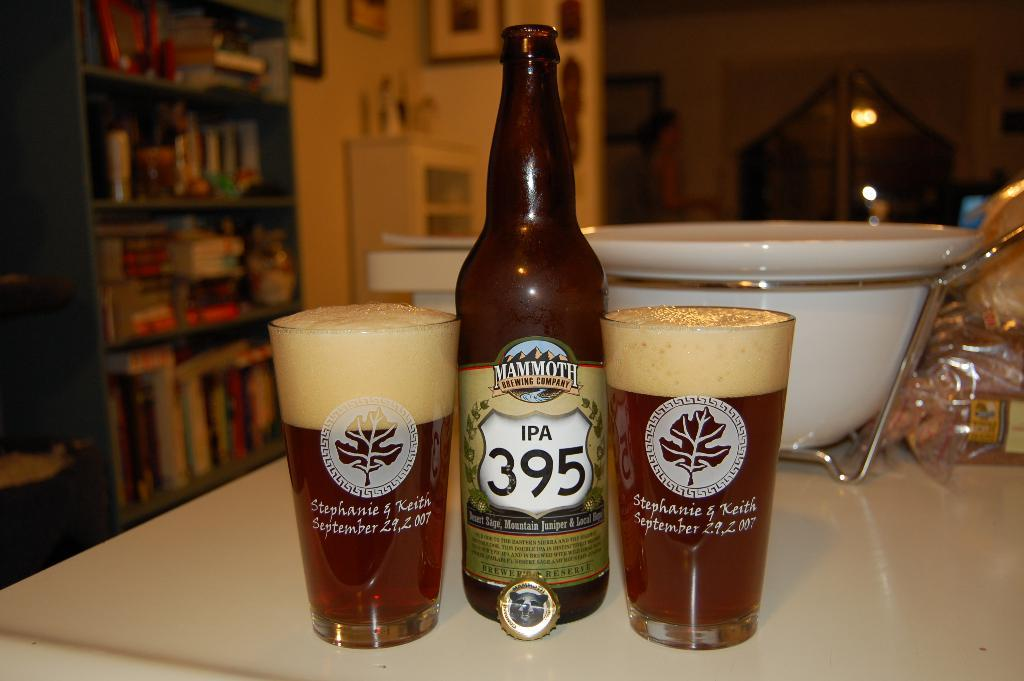<image>
Give a short and clear explanation of the subsequent image. Two full glasses of ale sit next to a 395 IPA bottle 